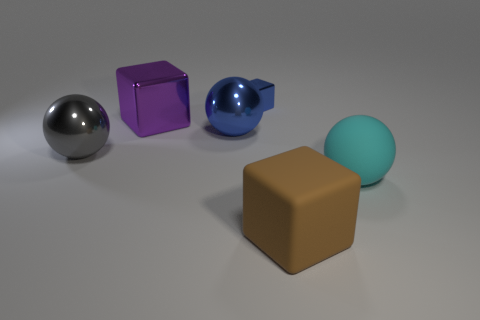Could you describe the lighting in the scene and where it might be coming from? The lighting in the image seems diffused, suggesting an ambient light source that is likely positioned above the composition, accentuating the objects' shapes and providing a slight shadow beneath them. This uniform lighting helps to bring out the textures and contours of the objects without creating overly harsh shadows. 